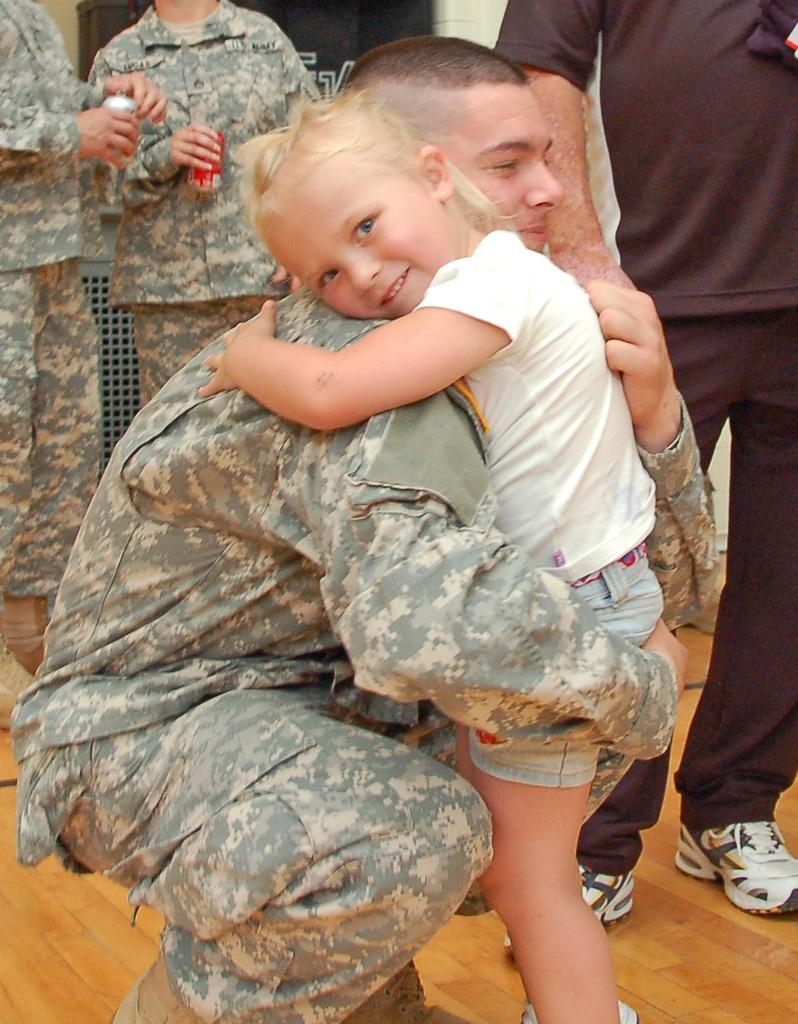How many people are in the image? There are a few people in the image. What are some of the people doing in the image? Some of the people are holding twins. What can be seen in the background of the image? There is a wall in the background of the image. What is the riddle that the queen is trying to solve in the image? There is no queen or riddle present in the image. What is the base of the structure that the people are standing on in the image? There is no structure or base present in the image; it only shows people holding twins with a wall in the background. 